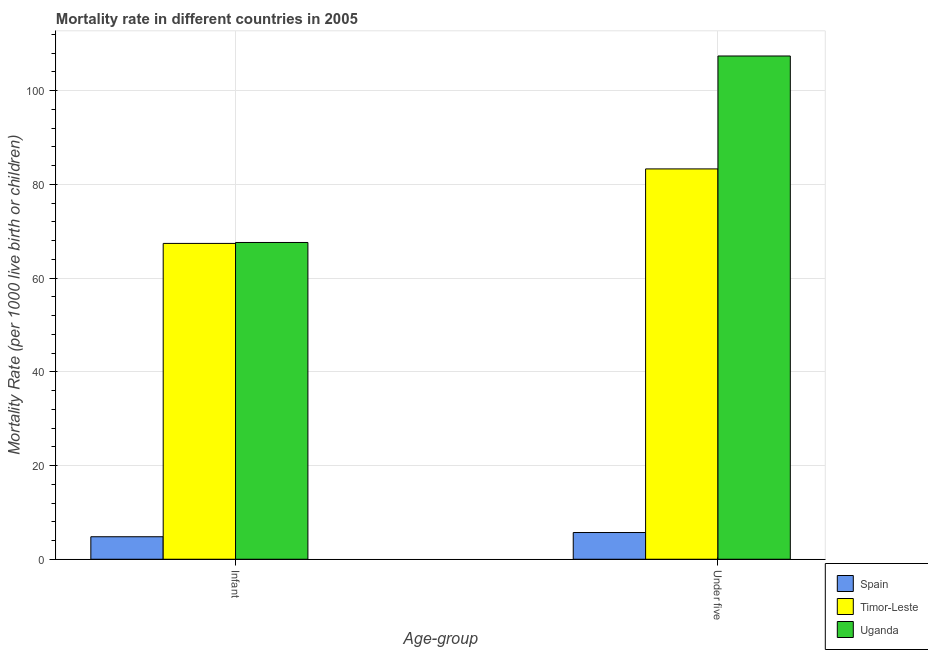Are the number of bars per tick equal to the number of legend labels?
Your response must be concise. Yes. Are the number of bars on each tick of the X-axis equal?
Your answer should be very brief. Yes. What is the label of the 2nd group of bars from the left?
Provide a succinct answer. Under five. What is the infant mortality rate in Uganda?
Your response must be concise. 67.6. Across all countries, what is the maximum infant mortality rate?
Keep it short and to the point. 67.6. In which country was the infant mortality rate maximum?
Provide a short and direct response. Uganda. In which country was the under-5 mortality rate minimum?
Give a very brief answer. Spain. What is the total under-5 mortality rate in the graph?
Provide a short and direct response. 196.4. What is the difference between the under-5 mortality rate in Spain and that in Timor-Leste?
Make the answer very short. -77.6. What is the difference between the infant mortality rate in Uganda and the under-5 mortality rate in Timor-Leste?
Make the answer very short. -15.7. What is the average infant mortality rate per country?
Provide a succinct answer. 46.6. What is the difference between the infant mortality rate and under-5 mortality rate in Uganda?
Provide a short and direct response. -39.8. What is the ratio of the infant mortality rate in Timor-Leste to that in Spain?
Provide a short and direct response. 14.04. Is the infant mortality rate in Timor-Leste less than that in Uganda?
Make the answer very short. Yes. What does the 3rd bar from the left in Under five represents?
Your answer should be very brief. Uganda. What does the 3rd bar from the right in Infant represents?
Offer a terse response. Spain. How many bars are there?
Keep it short and to the point. 6. How many countries are there in the graph?
Give a very brief answer. 3. What is the difference between two consecutive major ticks on the Y-axis?
Your response must be concise. 20. How are the legend labels stacked?
Ensure brevity in your answer.  Vertical. What is the title of the graph?
Provide a succinct answer. Mortality rate in different countries in 2005. Does "Singapore" appear as one of the legend labels in the graph?
Provide a short and direct response. No. What is the label or title of the X-axis?
Offer a very short reply. Age-group. What is the label or title of the Y-axis?
Provide a short and direct response. Mortality Rate (per 1000 live birth or children). What is the Mortality Rate (per 1000 live birth or children) of Spain in Infant?
Provide a short and direct response. 4.8. What is the Mortality Rate (per 1000 live birth or children) in Timor-Leste in Infant?
Provide a short and direct response. 67.4. What is the Mortality Rate (per 1000 live birth or children) of Uganda in Infant?
Offer a terse response. 67.6. What is the Mortality Rate (per 1000 live birth or children) of Timor-Leste in Under five?
Provide a succinct answer. 83.3. What is the Mortality Rate (per 1000 live birth or children) in Uganda in Under five?
Keep it short and to the point. 107.4. Across all Age-group, what is the maximum Mortality Rate (per 1000 live birth or children) of Timor-Leste?
Make the answer very short. 83.3. Across all Age-group, what is the maximum Mortality Rate (per 1000 live birth or children) of Uganda?
Give a very brief answer. 107.4. Across all Age-group, what is the minimum Mortality Rate (per 1000 live birth or children) of Timor-Leste?
Your response must be concise. 67.4. Across all Age-group, what is the minimum Mortality Rate (per 1000 live birth or children) in Uganda?
Keep it short and to the point. 67.6. What is the total Mortality Rate (per 1000 live birth or children) in Timor-Leste in the graph?
Offer a terse response. 150.7. What is the total Mortality Rate (per 1000 live birth or children) in Uganda in the graph?
Keep it short and to the point. 175. What is the difference between the Mortality Rate (per 1000 live birth or children) in Timor-Leste in Infant and that in Under five?
Your answer should be very brief. -15.9. What is the difference between the Mortality Rate (per 1000 live birth or children) of Uganda in Infant and that in Under five?
Your response must be concise. -39.8. What is the difference between the Mortality Rate (per 1000 live birth or children) of Spain in Infant and the Mortality Rate (per 1000 live birth or children) of Timor-Leste in Under five?
Your response must be concise. -78.5. What is the difference between the Mortality Rate (per 1000 live birth or children) of Spain in Infant and the Mortality Rate (per 1000 live birth or children) of Uganda in Under five?
Offer a terse response. -102.6. What is the average Mortality Rate (per 1000 live birth or children) of Spain per Age-group?
Ensure brevity in your answer.  5.25. What is the average Mortality Rate (per 1000 live birth or children) in Timor-Leste per Age-group?
Ensure brevity in your answer.  75.35. What is the average Mortality Rate (per 1000 live birth or children) in Uganda per Age-group?
Offer a terse response. 87.5. What is the difference between the Mortality Rate (per 1000 live birth or children) of Spain and Mortality Rate (per 1000 live birth or children) of Timor-Leste in Infant?
Make the answer very short. -62.6. What is the difference between the Mortality Rate (per 1000 live birth or children) of Spain and Mortality Rate (per 1000 live birth or children) of Uganda in Infant?
Keep it short and to the point. -62.8. What is the difference between the Mortality Rate (per 1000 live birth or children) in Timor-Leste and Mortality Rate (per 1000 live birth or children) in Uganda in Infant?
Give a very brief answer. -0.2. What is the difference between the Mortality Rate (per 1000 live birth or children) of Spain and Mortality Rate (per 1000 live birth or children) of Timor-Leste in Under five?
Give a very brief answer. -77.6. What is the difference between the Mortality Rate (per 1000 live birth or children) of Spain and Mortality Rate (per 1000 live birth or children) of Uganda in Under five?
Your answer should be very brief. -101.7. What is the difference between the Mortality Rate (per 1000 live birth or children) of Timor-Leste and Mortality Rate (per 1000 live birth or children) of Uganda in Under five?
Offer a very short reply. -24.1. What is the ratio of the Mortality Rate (per 1000 live birth or children) of Spain in Infant to that in Under five?
Provide a short and direct response. 0.84. What is the ratio of the Mortality Rate (per 1000 live birth or children) in Timor-Leste in Infant to that in Under five?
Your response must be concise. 0.81. What is the ratio of the Mortality Rate (per 1000 live birth or children) of Uganda in Infant to that in Under five?
Your response must be concise. 0.63. What is the difference between the highest and the second highest Mortality Rate (per 1000 live birth or children) in Uganda?
Provide a short and direct response. 39.8. What is the difference between the highest and the lowest Mortality Rate (per 1000 live birth or children) of Uganda?
Provide a succinct answer. 39.8. 